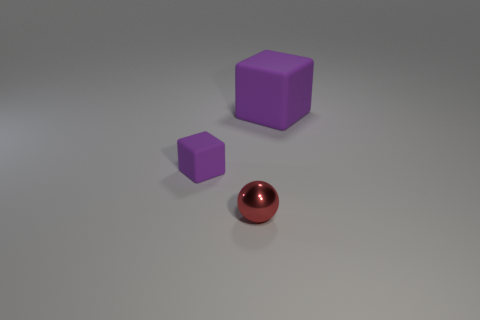Are there any shiny things behind the small purple rubber thing?
Offer a terse response. No. There is a purple matte thing on the left side of the purple cube that is on the right side of the purple thing left of the large purple object; what size is it?
Give a very brief answer. Small. There is a purple rubber object to the right of the red shiny ball; does it have the same shape as the purple rubber thing that is left of the red sphere?
Keep it short and to the point. Yes. There is another purple rubber object that is the same shape as the big object; what size is it?
Provide a short and direct response. Small. How many red balls are the same material as the small red thing?
Provide a short and direct response. 0. What material is the tiny purple block?
Ensure brevity in your answer.  Rubber. The thing in front of the purple cube in front of the large matte object is what shape?
Your response must be concise. Sphere. What shape is the matte thing that is in front of the big rubber thing?
Your answer should be compact. Cube. What number of small matte things are the same color as the large cube?
Make the answer very short. 1. The big matte object is what color?
Keep it short and to the point. Purple. 